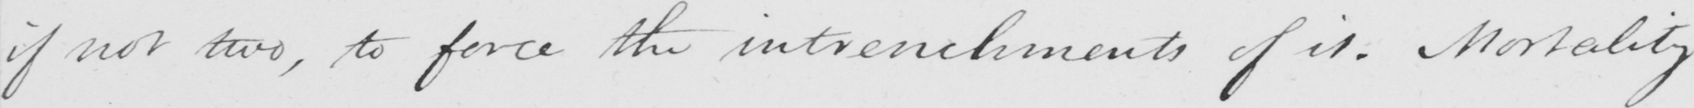Please transcribe the handwritten text in this image. if not two , to force the intrenchments of it . Mortality 